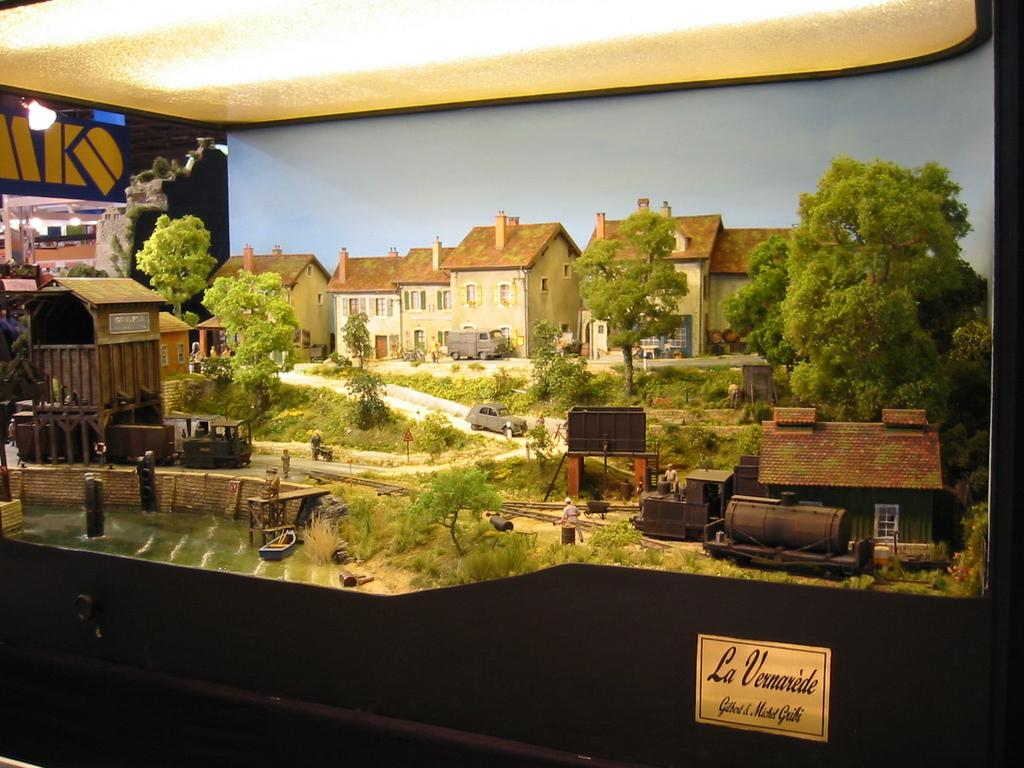<image>
Offer a succinct explanation of the picture presented. A large model is titled "La Vernarede" under bright lights. 